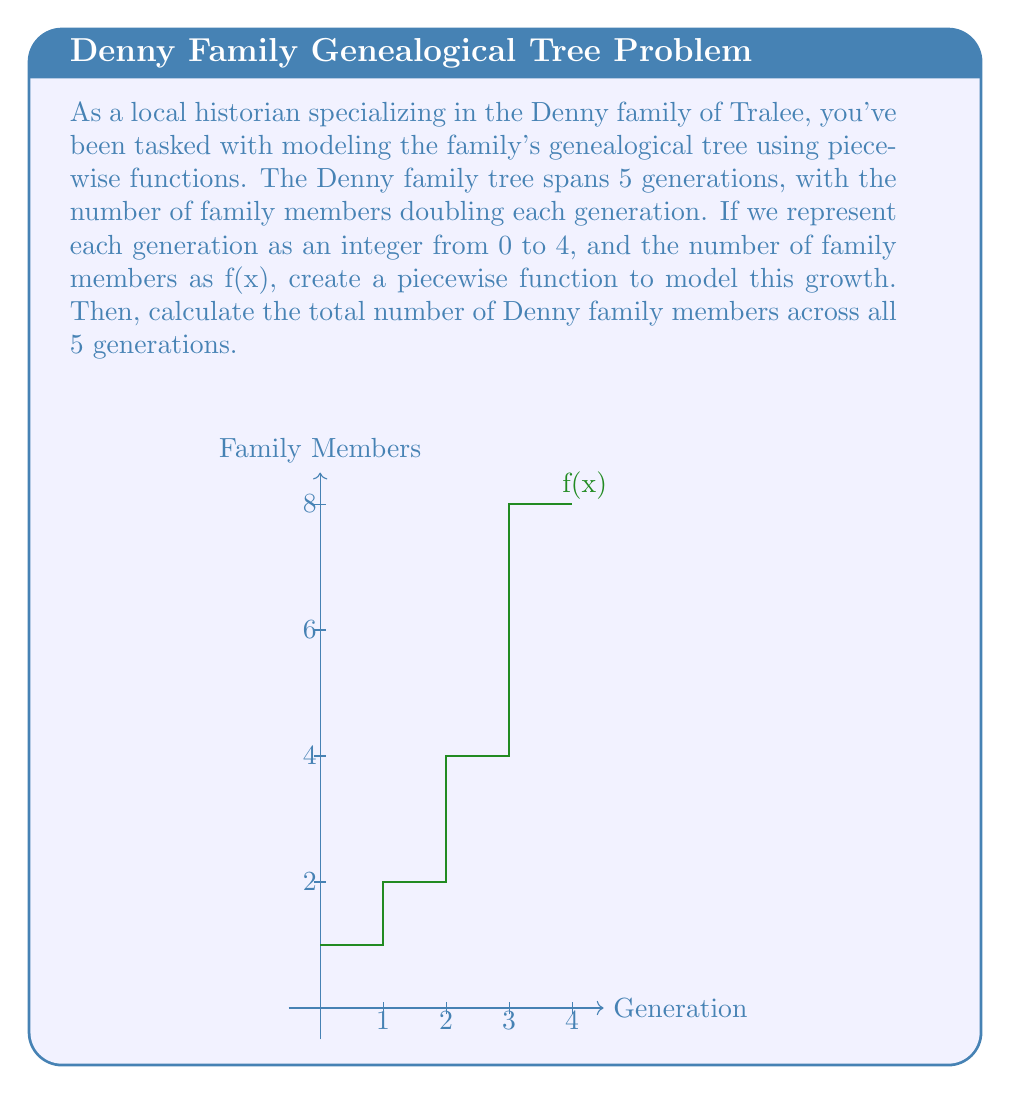Solve this math problem. Let's approach this step-by-step:

1) First, we need to define our piecewise function. Since the number of family members doubles each generation, we can represent this as:

   $$f(x) = \begin{cases}
   1 & \text{if } 0 \leq x < 1 \\
   2 & \text{if } 1 \leq x < 2 \\
   4 & \text{if } 2 \leq x < 3 \\
   8 & \text{if } 3 \leq x < 4 \\
   16 & \text{if } 4 \leq x < 5
   \end{cases}$$

2) To calculate the total number of Denny family members across all 5 generations, we need to sum the values of f(x) for x = 0, 1, 2, 3, and 4.

3) Let's evaluate f(x) for each generation:
   
   f(0) = 1
   f(1) = 2
   f(2) = 4
   f(3) = 8
   f(4) = 16

4) Now, we sum these values:

   Total = 1 + 2 + 4 + 8 + 16 = 31

Therefore, the total number of Denny family members across all 5 generations is 31.
Answer: 31 family members 